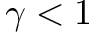Convert formula to latex. <formula><loc_0><loc_0><loc_500><loc_500>\gamma < 1</formula> 